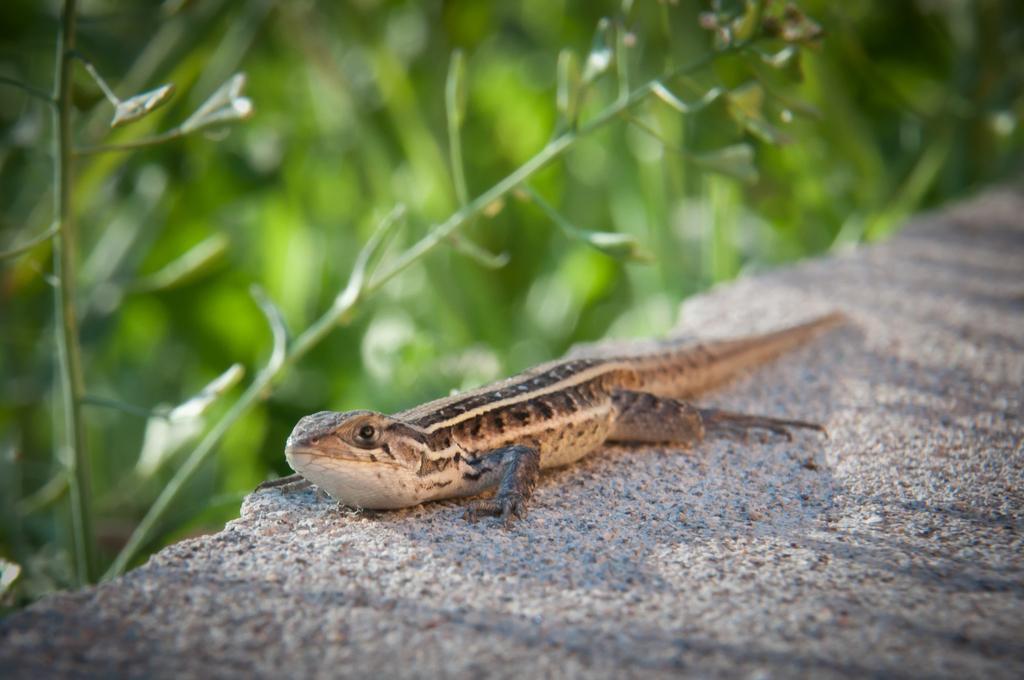Please provide a concise description of this image. In this picture we can see a reptile. Background is blurry. 